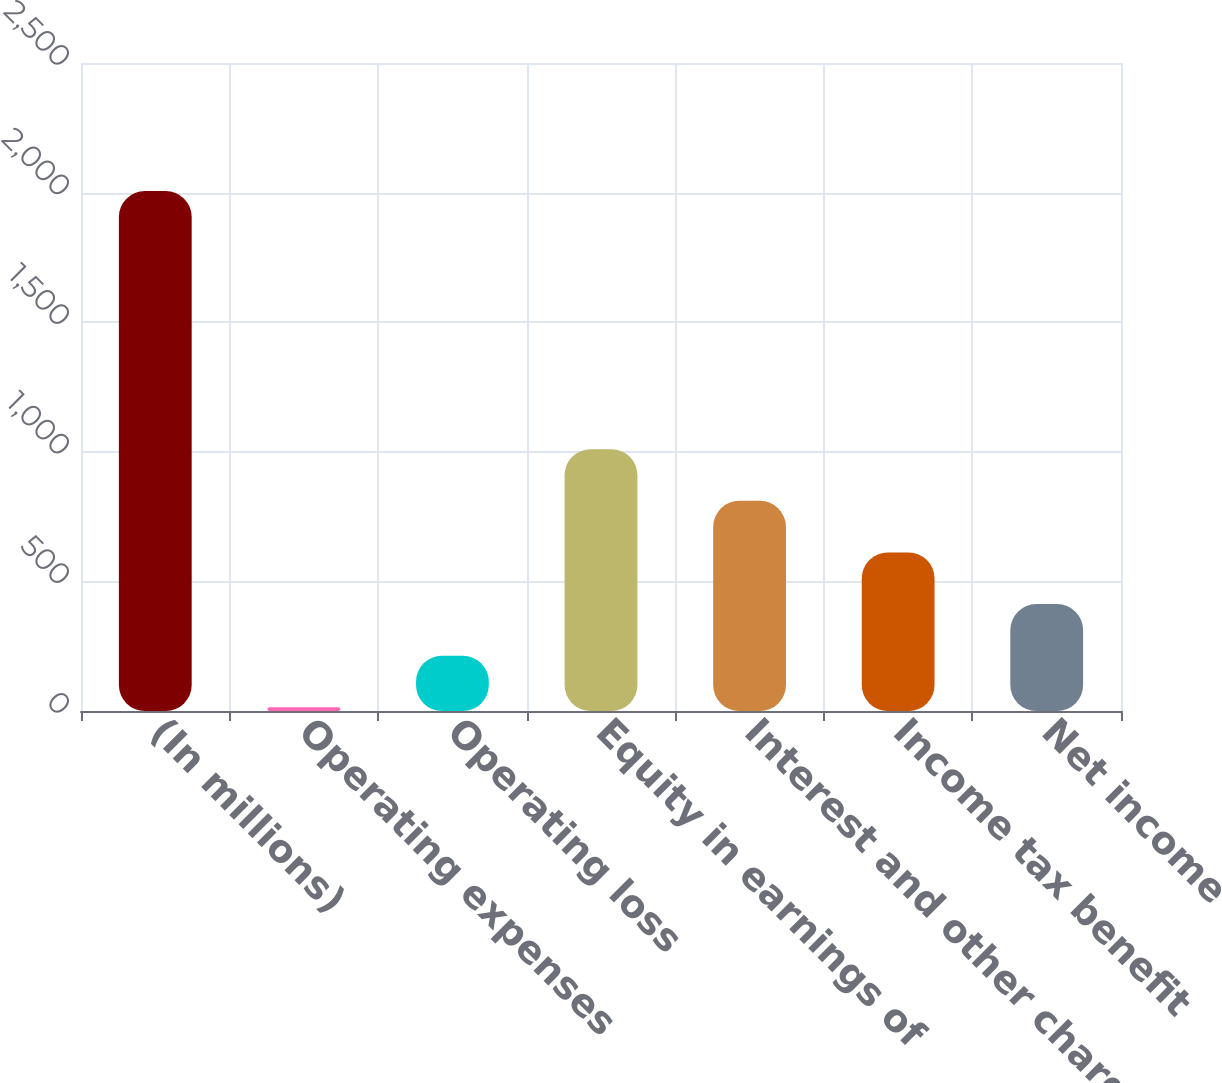Convert chart to OTSL. <chart><loc_0><loc_0><loc_500><loc_500><bar_chart><fcel>(In millions)<fcel>Operating expenses<fcel>Operating loss<fcel>Equity in earnings of<fcel>Interest and other charges<fcel>Income tax benefit<fcel>Net income<nl><fcel>2006<fcel>14<fcel>213.2<fcel>1010<fcel>810.8<fcel>611.6<fcel>412.4<nl></chart> 